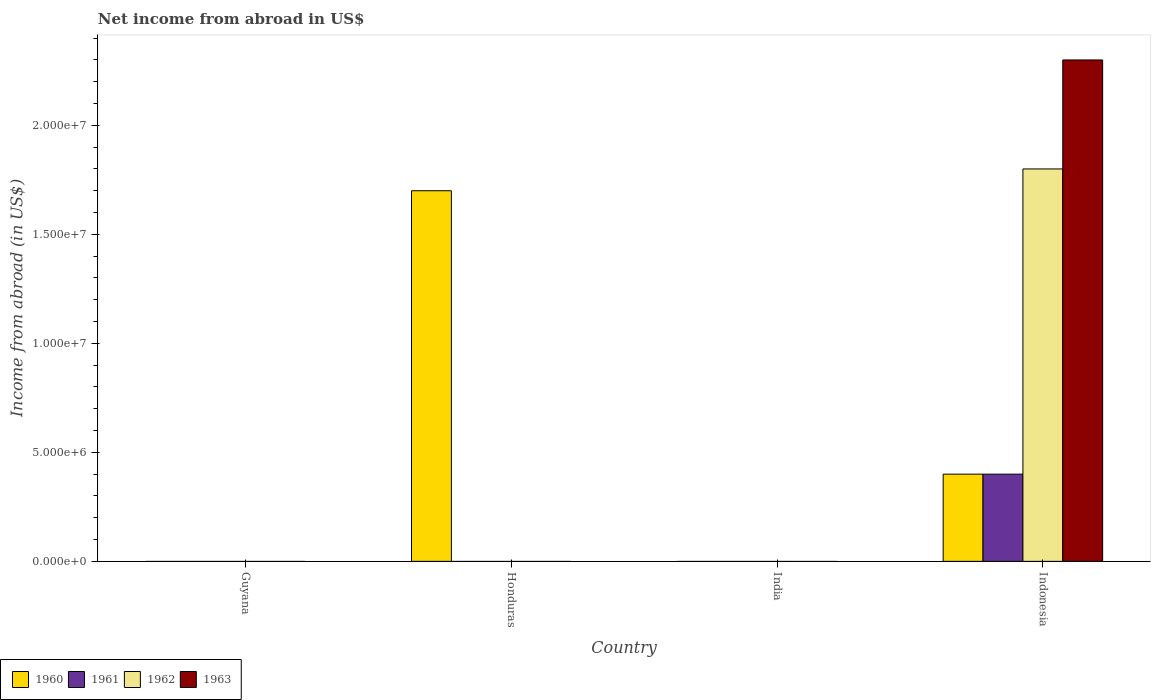How many different coloured bars are there?
Provide a succinct answer. 4. Are the number of bars on each tick of the X-axis equal?
Offer a terse response. No. How many bars are there on the 3rd tick from the left?
Provide a short and direct response. 0. How many bars are there on the 1st tick from the right?
Ensure brevity in your answer.  4. Across all countries, what is the maximum net income from abroad in 1961?
Make the answer very short. 4.00e+06. In which country was the net income from abroad in 1963 maximum?
Provide a short and direct response. Indonesia. What is the total net income from abroad in 1960 in the graph?
Ensure brevity in your answer.  2.10e+07. What is the difference between the net income from abroad in 1961 in Guyana and the net income from abroad in 1962 in India?
Make the answer very short. 0. What is the average net income from abroad in 1963 per country?
Provide a short and direct response. 5.75e+06. What is the difference between the net income from abroad of/in 1960 and net income from abroad of/in 1963 in Indonesia?
Your response must be concise. -1.90e+07. What is the difference between the highest and the lowest net income from abroad in 1963?
Provide a short and direct response. 2.30e+07. Is it the case that in every country, the sum of the net income from abroad in 1960 and net income from abroad in 1962 is greater than the sum of net income from abroad in 1963 and net income from abroad in 1961?
Ensure brevity in your answer.  No. Is it the case that in every country, the sum of the net income from abroad in 1962 and net income from abroad in 1963 is greater than the net income from abroad in 1961?
Keep it short and to the point. No. How many bars are there?
Ensure brevity in your answer.  5. Are all the bars in the graph horizontal?
Offer a terse response. No. Does the graph contain grids?
Keep it short and to the point. No. Where does the legend appear in the graph?
Your answer should be compact. Bottom left. What is the title of the graph?
Provide a succinct answer. Net income from abroad in US$. What is the label or title of the Y-axis?
Your response must be concise. Income from abroad (in US$). What is the Income from abroad (in US$) of 1962 in Guyana?
Provide a short and direct response. 0. What is the Income from abroad (in US$) in 1960 in Honduras?
Give a very brief answer. 1.70e+07. What is the Income from abroad (in US$) in 1961 in Honduras?
Ensure brevity in your answer.  0. What is the Income from abroad (in US$) in 1963 in Honduras?
Give a very brief answer. 0. What is the Income from abroad (in US$) of 1962 in India?
Ensure brevity in your answer.  0. What is the Income from abroad (in US$) of 1960 in Indonesia?
Make the answer very short. 4.00e+06. What is the Income from abroad (in US$) in 1961 in Indonesia?
Your answer should be very brief. 4.00e+06. What is the Income from abroad (in US$) in 1962 in Indonesia?
Your answer should be compact. 1.80e+07. What is the Income from abroad (in US$) of 1963 in Indonesia?
Keep it short and to the point. 2.30e+07. Across all countries, what is the maximum Income from abroad (in US$) of 1960?
Ensure brevity in your answer.  1.70e+07. Across all countries, what is the maximum Income from abroad (in US$) of 1961?
Provide a succinct answer. 4.00e+06. Across all countries, what is the maximum Income from abroad (in US$) in 1962?
Your answer should be compact. 1.80e+07. Across all countries, what is the maximum Income from abroad (in US$) in 1963?
Your response must be concise. 2.30e+07. Across all countries, what is the minimum Income from abroad (in US$) of 1960?
Provide a succinct answer. 0. What is the total Income from abroad (in US$) of 1960 in the graph?
Provide a short and direct response. 2.10e+07. What is the total Income from abroad (in US$) of 1962 in the graph?
Provide a succinct answer. 1.80e+07. What is the total Income from abroad (in US$) in 1963 in the graph?
Ensure brevity in your answer.  2.30e+07. What is the difference between the Income from abroad (in US$) in 1960 in Honduras and that in Indonesia?
Keep it short and to the point. 1.30e+07. What is the difference between the Income from abroad (in US$) of 1960 in Honduras and the Income from abroad (in US$) of 1961 in Indonesia?
Give a very brief answer. 1.30e+07. What is the difference between the Income from abroad (in US$) of 1960 in Honduras and the Income from abroad (in US$) of 1962 in Indonesia?
Give a very brief answer. -1.00e+06. What is the difference between the Income from abroad (in US$) in 1960 in Honduras and the Income from abroad (in US$) in 1963 in Indonesia?
Your answer should be compact. -6.00e+06. What is the average Income from abroad (in US$) in 1960 per country?
Provide a succinct answer. 5.25e+06. What is the average Income from abroad (in US$) in 1962 per country?
Your answer should be very brief. 4.50e+06. What is the average Income from abroad (in US$) in 1963 per country?
Your answer should be very brief. 5.75e+06. What is the difference between the Income from abroad (in US$) in 1960 and Income from abroad (in US$) in 1962 in Indonesia?
Offer a terse response. -1.40e+07. What is the difference between the Income from abroad (in US$) in 1960 and Income from abroad (in US$) in 1963 in Indonesia?
Your answer should be compact. -1.90e+07. What is the difference between the Income from abroad (in US$) of 1961 and Income from abroad (in US$) of 1962 in Indonesia?
Make the answer very short. -1.40e+07. What is the difference between the Income from abroad (in US$) in 1961 and Income from abroad (in US$) in 1963 in Indonesia?
Keep it short and to the point. -1.90e+07. What is the difference between the Income from abroad (in US$) of 1962 and Income from abroad (in US$) of 1963 in Indonesia?
Your response must be concise. -5.00e+06. What is the ratio of the Income from abroad (in US$) of 1960 in Honduras to that in Indonesia?
Offer a very short reply. 4.25. What is the difference between the highest and the lowest Income from abroad (in US$) of 1960?
Your answer should be very brief. 1.70e+07. What is the difference between the highest and the lowest Income from abroad (in US$) in 1962?
Make the answer very short. 1.80e+07. What is the difference between the highest and the lowest Income from abroad (in US$) in 1963?
Give a very brief answer. 2.30e+07. 